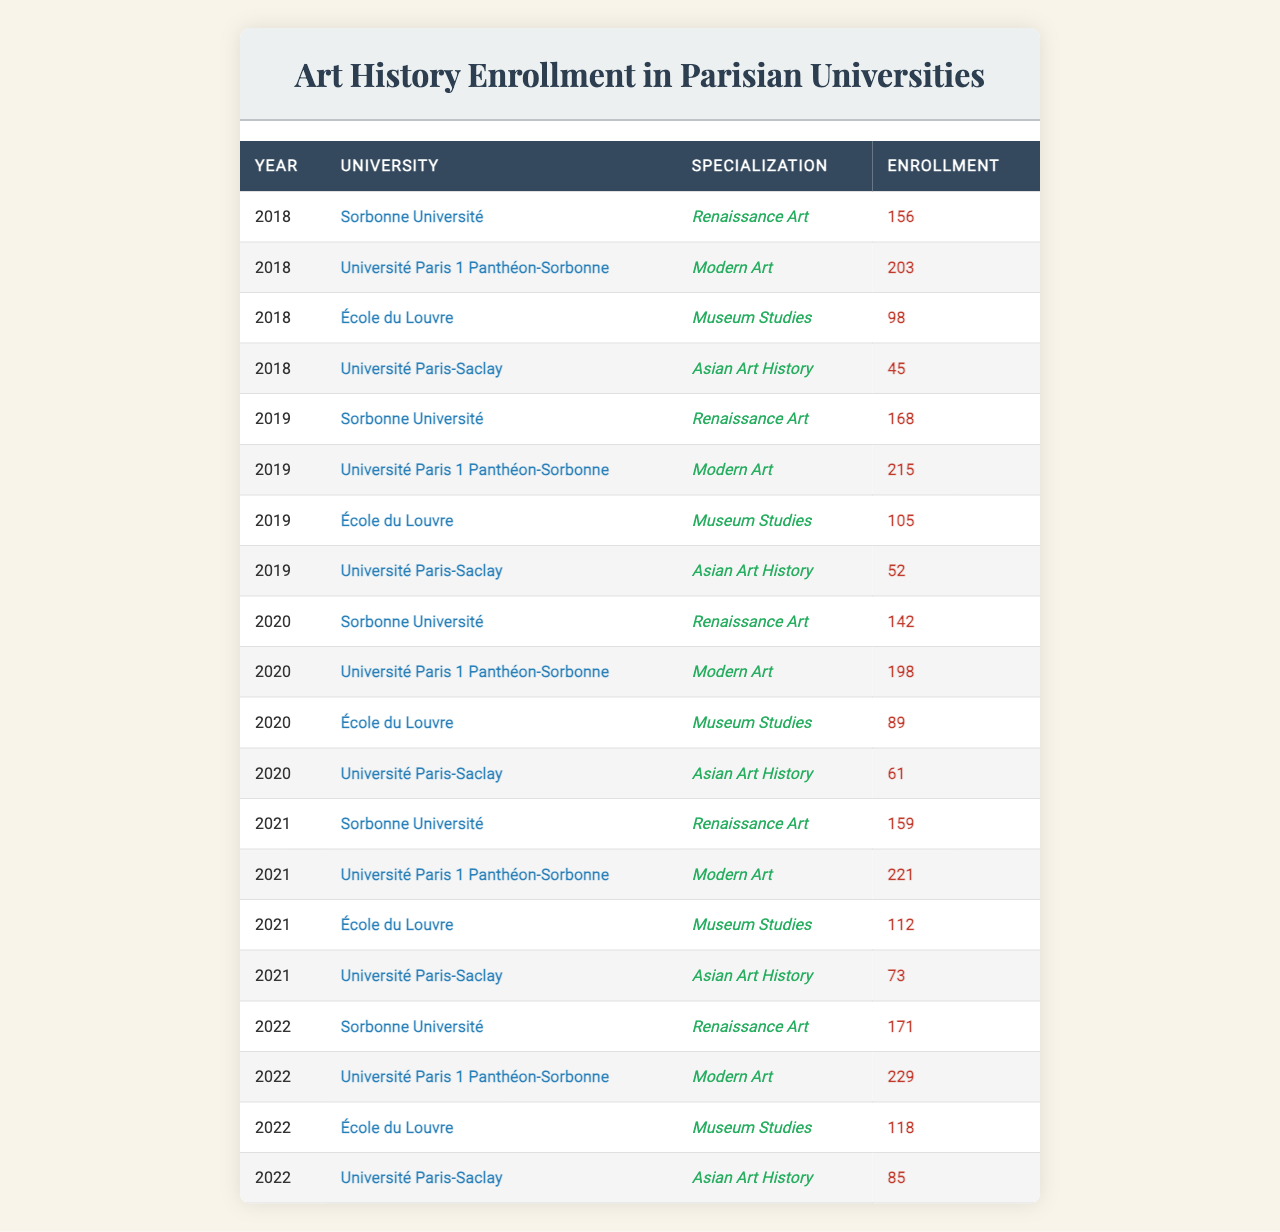What was the enrollment for Museum Studies at École du Louvre in 2022? The table shows that in 2022, École du Louvre had an enrollment of 118 students for the Museum Studies specialization.
Answer: 118 Which university had the highest enrollment in Modern Art over the years? By examining the data for each year, the University Paris 1 Panthéon-Sorbonne consistently has the highest enrollment in Modern Art, with 229 in 2022 being the peak.
Answer: Université Paris 1 Panthéon-Sorbonne What is the total enrollment for Renaissance Art across all universities in 2019? The enrollments for Renaissance Art in 2019 are as follows: Sorbonne Université: 168. Summing these values gives 168.
Answer: 168 Did the enrollment for Asian Art History at Université Paris-Saclay increase from 2018 to 2022? The enrollment for Asian Art History at Université Paris-Saclay was 45 in 2018 and increased to 85 in 2022, indicating an increase.
Answer: Yes What was the average enrollment for Museum Studies from 2018 to 2022? The enrollments for Museum Studies from 2018 to 2022 are: 98, 105, 89, 112, 118. Calculating the average: (98 + 105 + 89 + 112 + 118) = 522 and dividing by 5 gives 104.4.
Answer: 104.4 Which specialization had the lowest total enrollment over the entire period from 2018 to 2022? Summing the enrollment for each specialization across all years reveals Asian Art History at Université Paris-Saclay had the lowest total, with 45 + 52 + 61 + 73 + 85 totaling 316.
Answer: Asian Art History Was there any year when enrollment for Renaissance Art dropped compared to the previous year? Yes, the enrollment for Renaissance Art dropped from 168 in 2019 to 142 in 2020.
Answer: Yes Calculating all the enrollments from 2018 to 2022, what is the total enrollment for all specializations combined? Adding all the enrollment figures from the table gives a total of 1085 across all specializations and years.
Answer: 1085 Which year experienced the highest total enrollment across all universities? By summing the total enrollments for each year, 2022 had the highest total, with a final tally of 605 across all specializations.
Answer: 2022 How much did the enrollment in Modern Art at Université Paris 1 Panthéon-Sorbonne increase from 2018 to 2022? The enrollment for Modern Art at Université Paris 1 Panthéon-Sorbonne was 203 in 2018 and rose to 229 in 2022, an increase of 26.
Answer: 26 